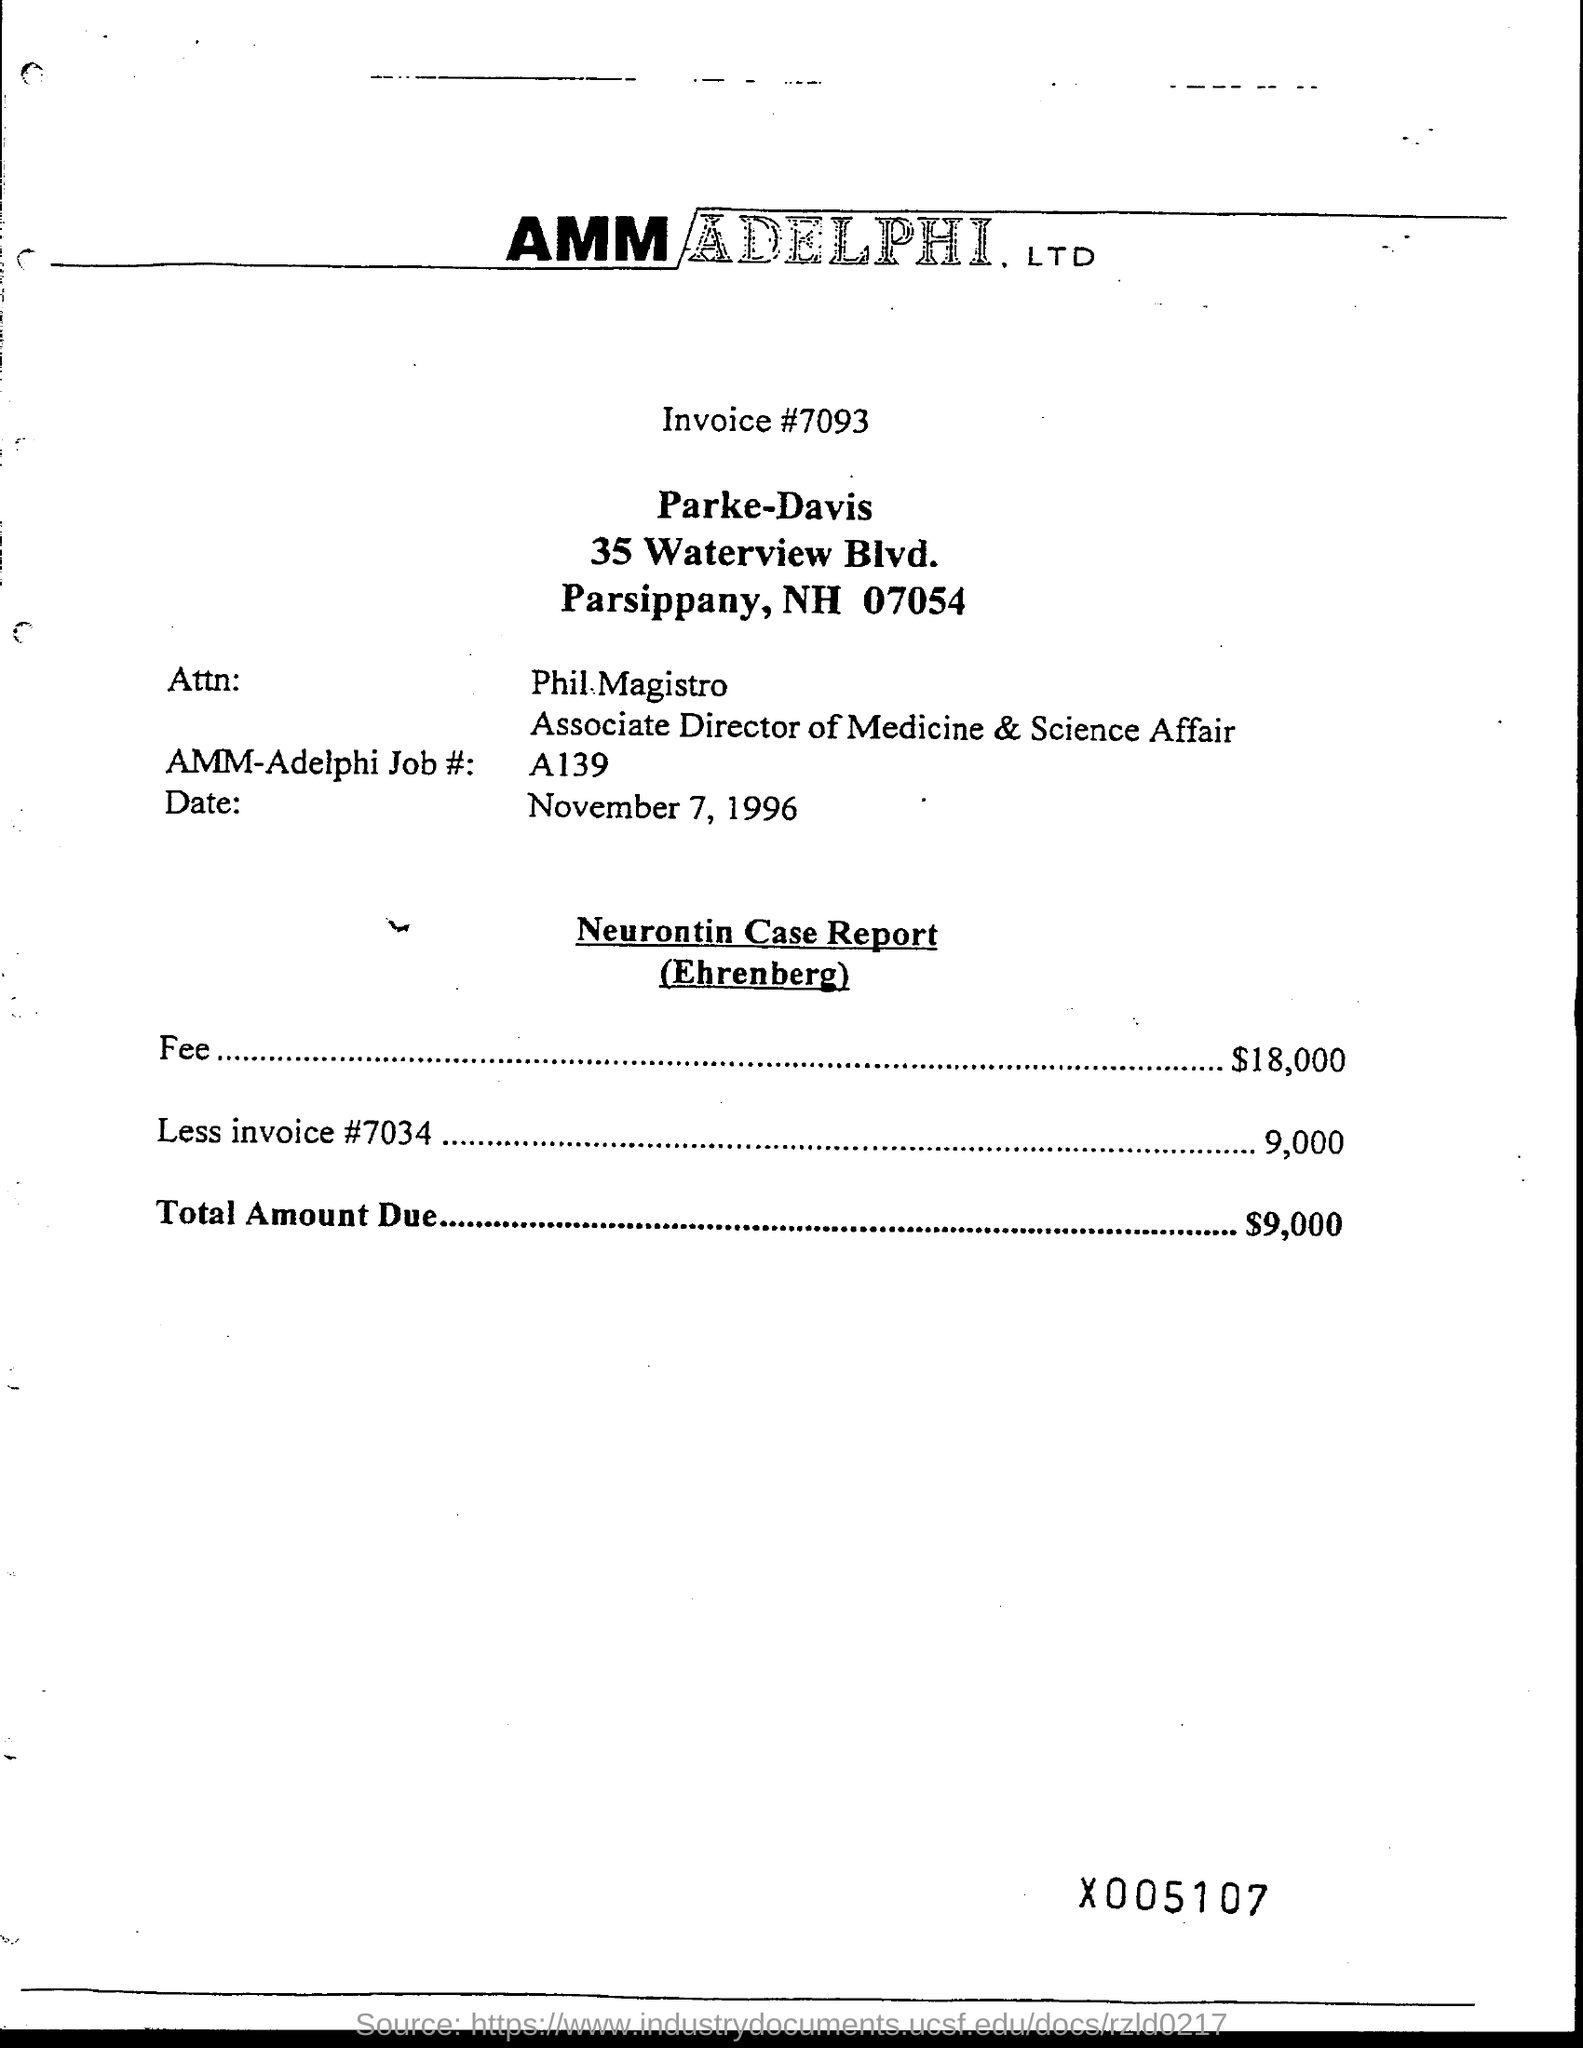What is the invoice number ?
Provide a short and direct response. #7093. What is the fee amount?
Ensure brevity in your answer.  18000. What is total amount due?
Keep it short and to the point. 9000. 